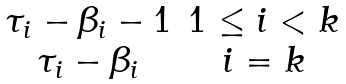Convert formula to latex. <formula><loc_0><loc_0><loc_500><loc_500>\begin{matrix} \tau _ { i } - \beta _ { i } - 1 & 1 \leq i < k \\ \tau _ { i } - \beta _ { i } & i = k \end{matrix}</formula> 